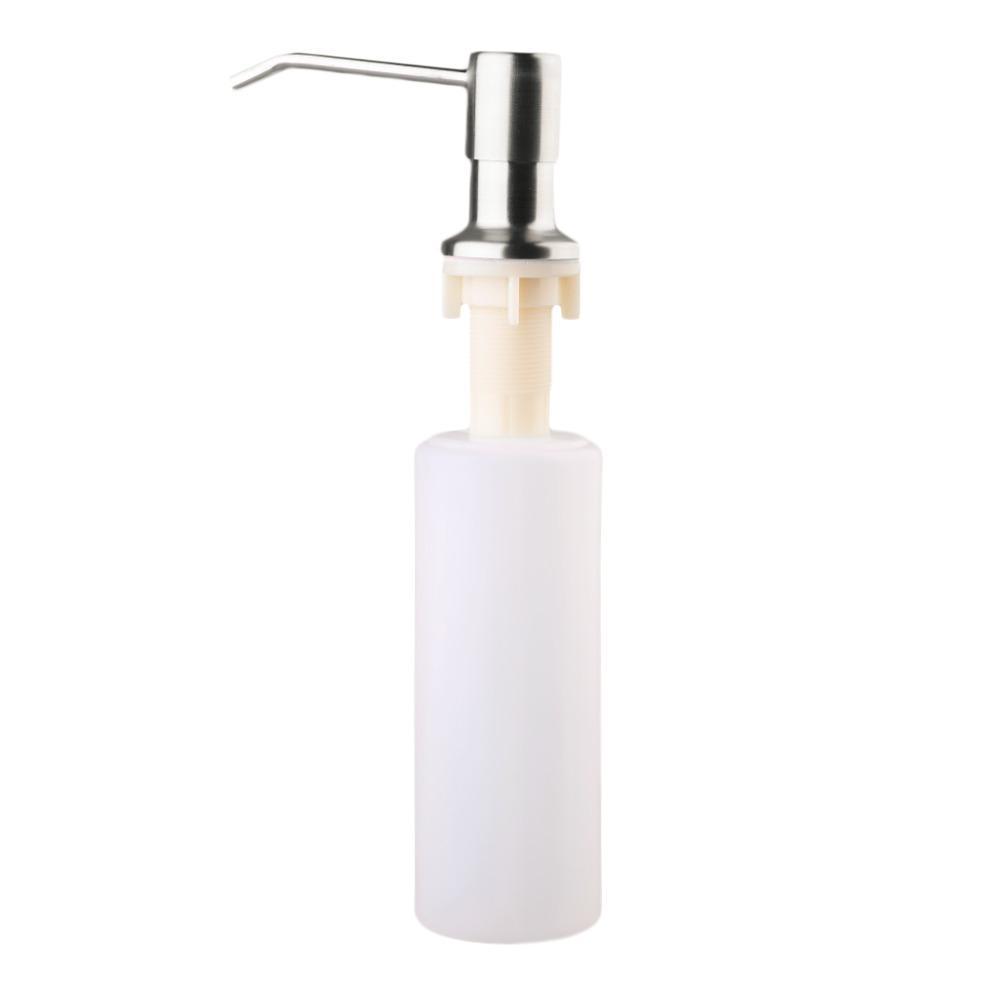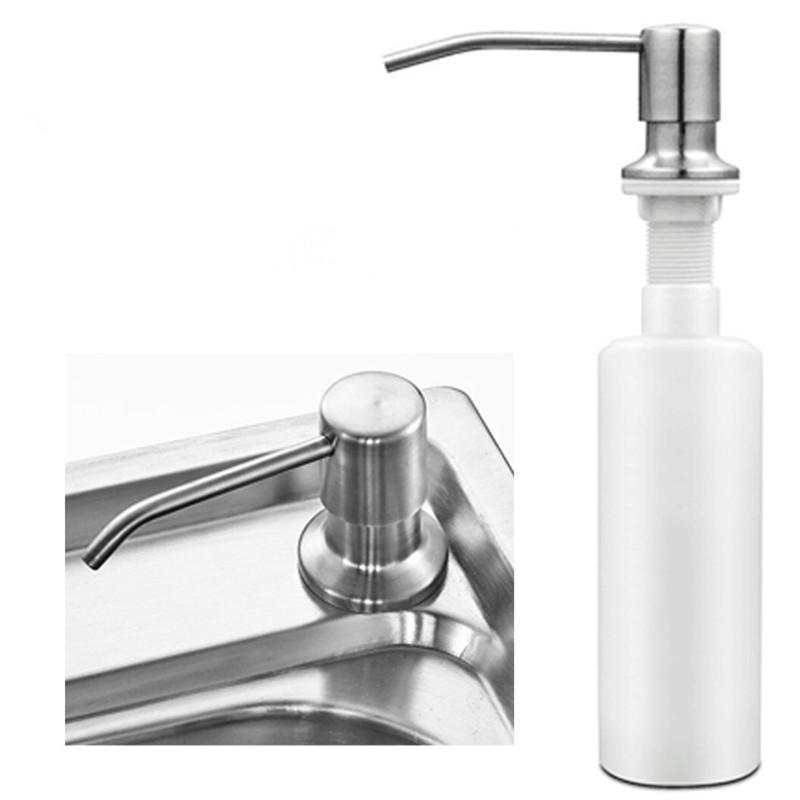The first image is the image on the left, the second image is the image on the right. Considering the images on both sides, is "The pump spigots are all facing to the left." valid? Answer yes or no. Yes. 